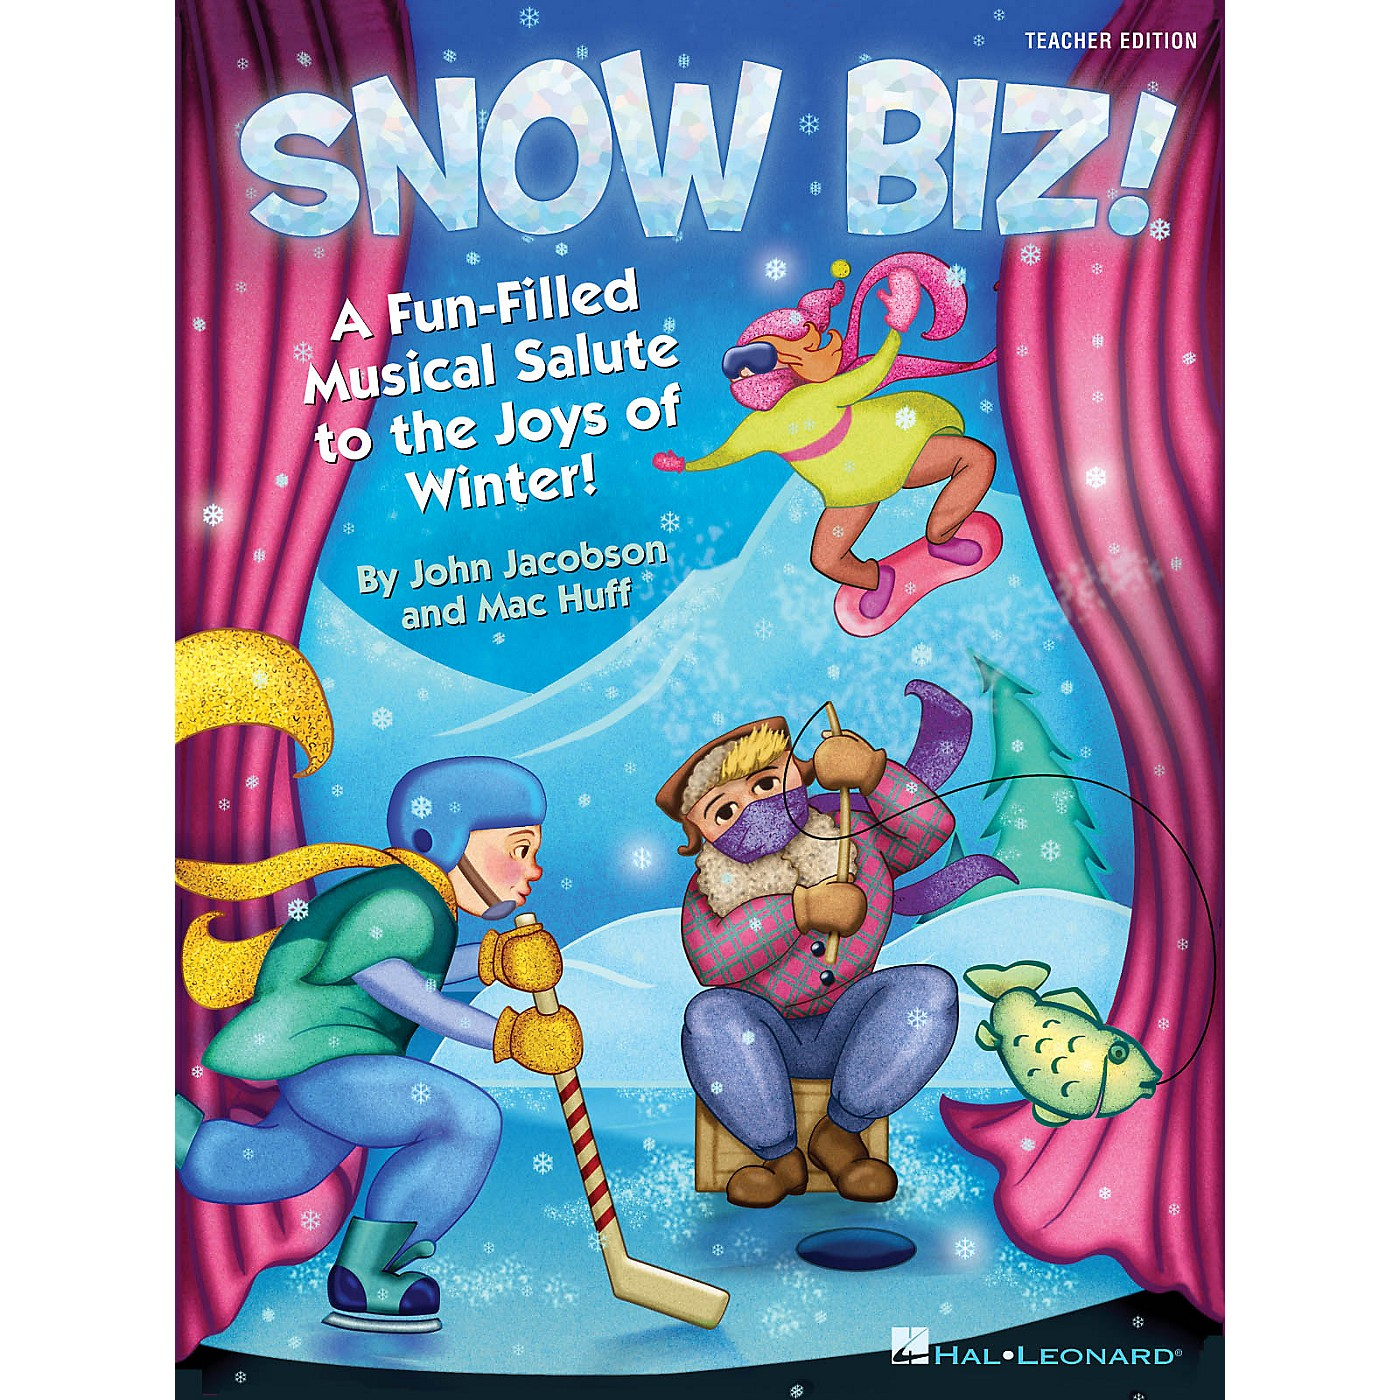Can you describe the activities the characters are engaged in and how they contribute to the theme of the material? Certainly! The characters in the image are engaged in various winter-themed activities that contribute to the overall fun and festive atmosphere of the material. On the left, we see a character dressed warmly and playing hockey, which is a classic winter sport. This adds an element of action and excitement. In the center, there's a character wearing a colorful plaid shirt and hat, sitting on a stool while ice fishing, a tranquil and traditional winter pastime. This activity adds a peaceful and reflective component to the scene. The most whimsical activity is displayed at the top right, where a character in bright attire and sunglasses is joyously leaping into the air, embodying the sheer fun and exhilaration of winter. Together, these activities highlight the diverse ways one can enjoy winter, reinforcing the theme of celebrating the joys of the cold season. 